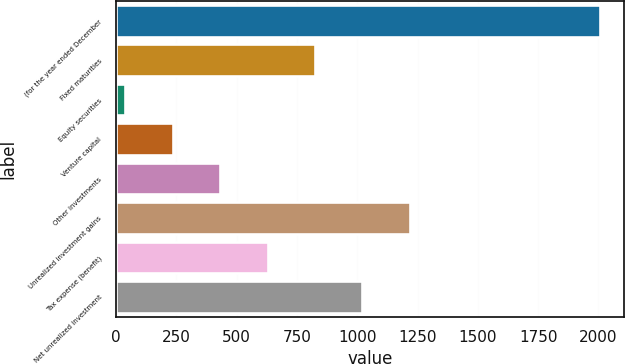Convert chart. <chart><loc_0><loc_0><loc_500><loc_500><bar_chart><fcel>(for the year ended December<fcel>Fixed maturities<fcel>Equity securities<fcel>Venture capital<fcel>Other investments<fcel>Unrealized investment gains<fcel>Tax expense (benefit)<fcel>Net unrealized investment<nl><fcel>2006<fcel>824.6<fcel>37<fcel>233.9<fcel>430.8<fcel>1218.4<fcel>627.7<fcel>1021.5<nl></chart> 